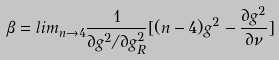Convert formula to latex. <formula><loc_0><loc_0><loc_500><loc_500>\beta = l i m _ { n \rightarrow 4 } \frac { 1 } { \partial g ^ { 2 } / \partial g _ { R } ^ { 2 } } [ ( n - 4 ) g ^ { 2 } - \frac { \partial g ^ { 2 } } { \partial \nu } ]</formula> 